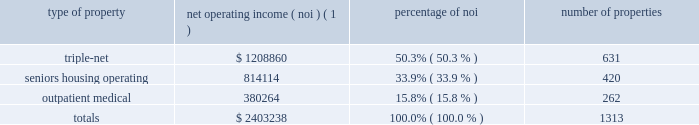Item 7 .
Management 2019s discussion and analysis of financial condition and results of operations the following discussion and analysis is based primarily on the consolidated financial statements of welltower inc .
For the periods presented and should be read together with the notes thereto contained in this annual report on form 10-k .
Other important factors are identified in 201citem 1 2014 business 201d and 201citem 1a 2014 risk factors 201d above .
Executive summary company overview welltower inc .
( nyse : hcn ) , an s&p 500 company headquartered in toledo , ohio , is driving the transformation of health care infrastructure .
The company invests with leading seniors housing operators , post- acute providers and health systems to fund the real estate and infrastructure needed to scale innovative care delivery models and improve people 2019s wellness and overall health care experience .
Welltowertm , a real estate investment trust ( 201creit 201d ) , owns interests in properties concentrated in major , high-growth markets in the united states , canada and the united kingdom , consisting of seniors housing and post-acute communities and outpatient medical properties .
Our capital programs , when combined with comprehensive planning , development and property management services , make us a single-source solution for acquiring , planning , developing , managing , repositioning and monetizing real estate assets .
The table summarizes our consolidated portfolio for the year ended december 31 , 2016 ( dollars in thousands ) : type of property net operating income ( noi ) ( 1 ) percentage of number of properties .
( 1 ) excludes our share of investments in unconsolidated entities and non-segment/corporate noi .
Entities in which we have a joint venture with a minority partner are shown at 100% ( 100 % ) of the joint venture amount .
Business strategy our primary objectives are to protect stockholder capital and enhance stockholder value .
We seek to pay consistent cash dividends to stockholders and create opportunities to increase dividend payments to stockholders as a result of annual increases in net operating income and portfolio growth .
To meet these objectives , we invest across the full spectrum of seniors housing and health care real estate and diversify our investment portfolio by property type , relationship and geographic location .
Substantially all of our revenues are derived from operating lease rentals , resident fees and services , and interest earned on outstanding loans receivable .
These items represent our primary sources of liquidity to fund distributions and depend upon the continued ability of our obligors to make contractual rent and interest payments to us and the profitability of our operating properties .
To the extent that our customers/partners experience operating difficulties and become unable to generate sufficient cash to make payments to us , there could be a material adverse impact on our consolidated results of operations , liquidity and/or financial condition .
To mitigate this risk , we monitor our investments through a variety of methods determined by the type of property .
Our proactive and comprehensive asset management process for seniors housing properties generally includes review of monthly financial statements and other operating data for each property , review of obligor/ partner creditworthiness , property inspections , and review of covenant compliance relating to licensure , real estate taxes , letters of credit and other collateral .
Our internal property management division actively manages and monitors the outpatient medical portfolio with a comprehensive process including review of tenant relations , lease expirations , the mix of health service providers , hospital/health system relationships , property performance .
What portion of the total properties is related to triple-net? 
Computations: (631 / 1313)
Answer: 0.48058. Item 7 .
Management 2019s discussion and analysis of financial condition and results of operations the following discussion and analysis is based primarily on the consolidated financial statements of welltower inc .
For the periods presented and should be read together with the notes thereto contained in this annual report on form 10-k .
Other important factors are identified in 201citem 1 2014 business 201d and 201citem 1a 2014 risk factors 201d above .
Executive summary company overview welltower inc .
( nyse : hcn ) , an s&p 500 company headquartered in toledo , ohio , is driving the transformation of health care infrastructure .
The company invests with leading seniors housing operators , post- acute providers and health systems to fund the real estate and infrastructure needed to scale innovative care delivery models and improve people 2019s wellness and overall health care experience .
Welltowertm , a real estate investment trust ( 201creit 201d ) , owns interests in properties concentrated in major , high-growth markets in the united states , canada and the united kingdom , consisting of seniors housing and post-acute communities and outpatient medical properties .
Our capital programs , when combined with comprehensive planning , development and property management services , make us a single-source solution for acquiring , planning , developing , managing , repositioning and monetizing real estate assets .
The table summarizes our consolidated portfolio for the year ended december 31 , 2016 ( dollars in thousands ) : type of property net operating income ( noi ) ( 1 ) percentage of number of properties .
( 1 ) excludes our share of investments in unconsolidated entities and non-segment/corporate noi .
Entities in which we have a joint venture with a minority partner are shown at 100% ( 100 % ) of the joint venture amount .
Business strategy our primary objectives are to protect stockholder capital and enhance stockholder value .
We seek to pay consistent cash dividends to stockholders and create opportunities to increase dividend payments to stockholders as a result of annual increases in net operating income and portfolio growth .
To meet these objectives , we invest across the full spectrum of seniors housing and health care real estate and diversify our investment portfolio by property type , relationship and geographic location .
Substantially all of our revenues are derived from operating lease rentals , resident fees and services , and interest earned on outstanding loans receivable .
These items represent our primary sources of liquidity to fund distributions and depend upon the continued ability of our obligors to make contractual rent and interest payments to us and the profitability of our operating properties .
To the extent that our customers/partners experience operating difficulties and become unable to generate sufficient cash to make payments to us , there could be a material adverse impact on our consolidated results of operations , liquidity and/or financial condition .
To mitigate this risk , we monitor our investments through a variety of methods determined by the type of property .
Our proactive and comprehensive asset management process for seniors housing properties generally includes review of monthly financial statements and other operating data for each property , review of obligor/ partner creditworthiness , property inspections , and review of covenant compliance relating to licensure , real estate taxes , letters of credit and other collateral .
Our internal property management division actively manages and monitors the outpatient medical portfolio with a comprehensive process including review of tenant relations , lease expirations , the mix of health service providers , hospital/health system relationships , property performance .
By number of properties , outpatient medical was what percent of the total? 
Computations: (262 / 1313)
Answer: 0.19954. 